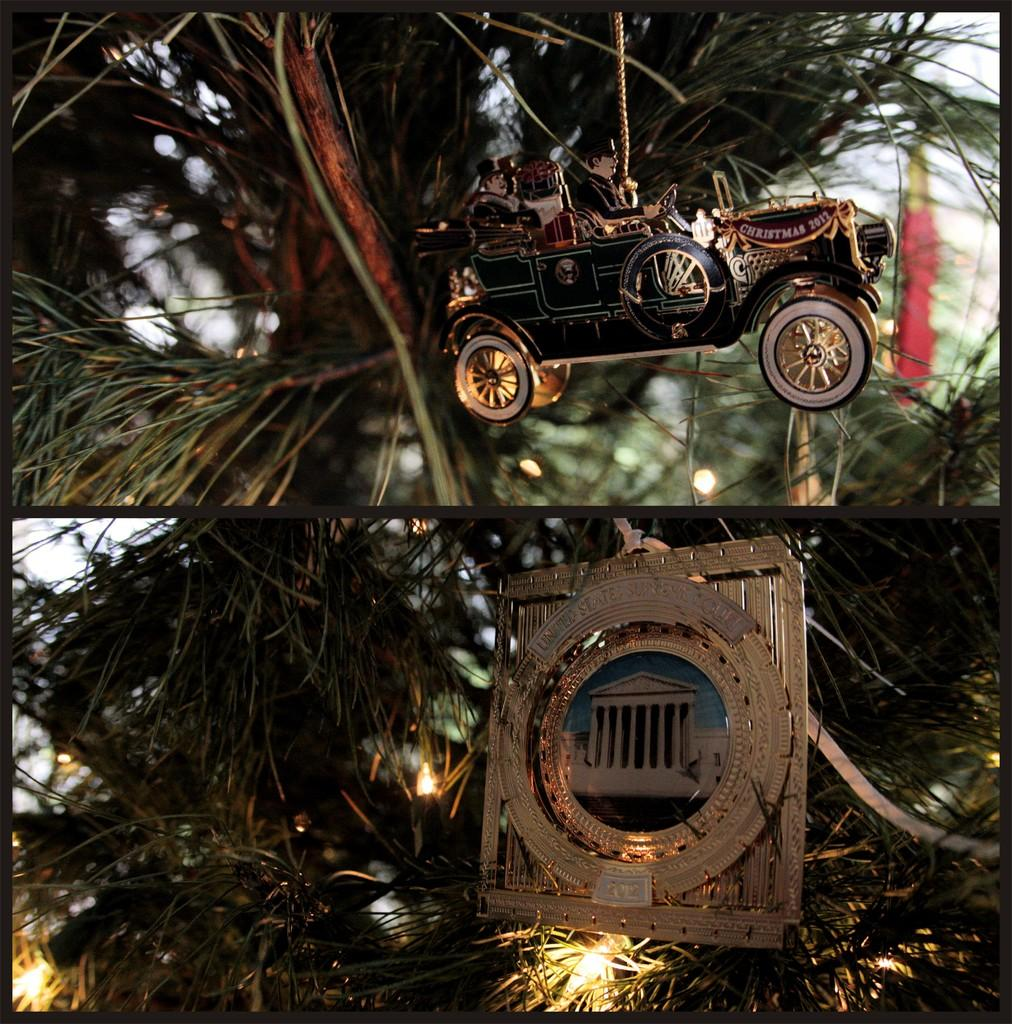What type of artwork is depicted in the image? The image is a collage. What type of object can be seen in the collage? There is a toy vehicle in the image. What surrounds the collage? There is a frame in the image. What type of illumination is present in the image? There are lights in the image. What type of natural elements are present in the image? There are trees in the image. What part of the natural environment is visible in the image? The sky is visible in the image. What type of note is being passed between the trees in the image? There is no note being passed between the trees in the image; the trees are part of the natural environment and are not involved in any human activity. 